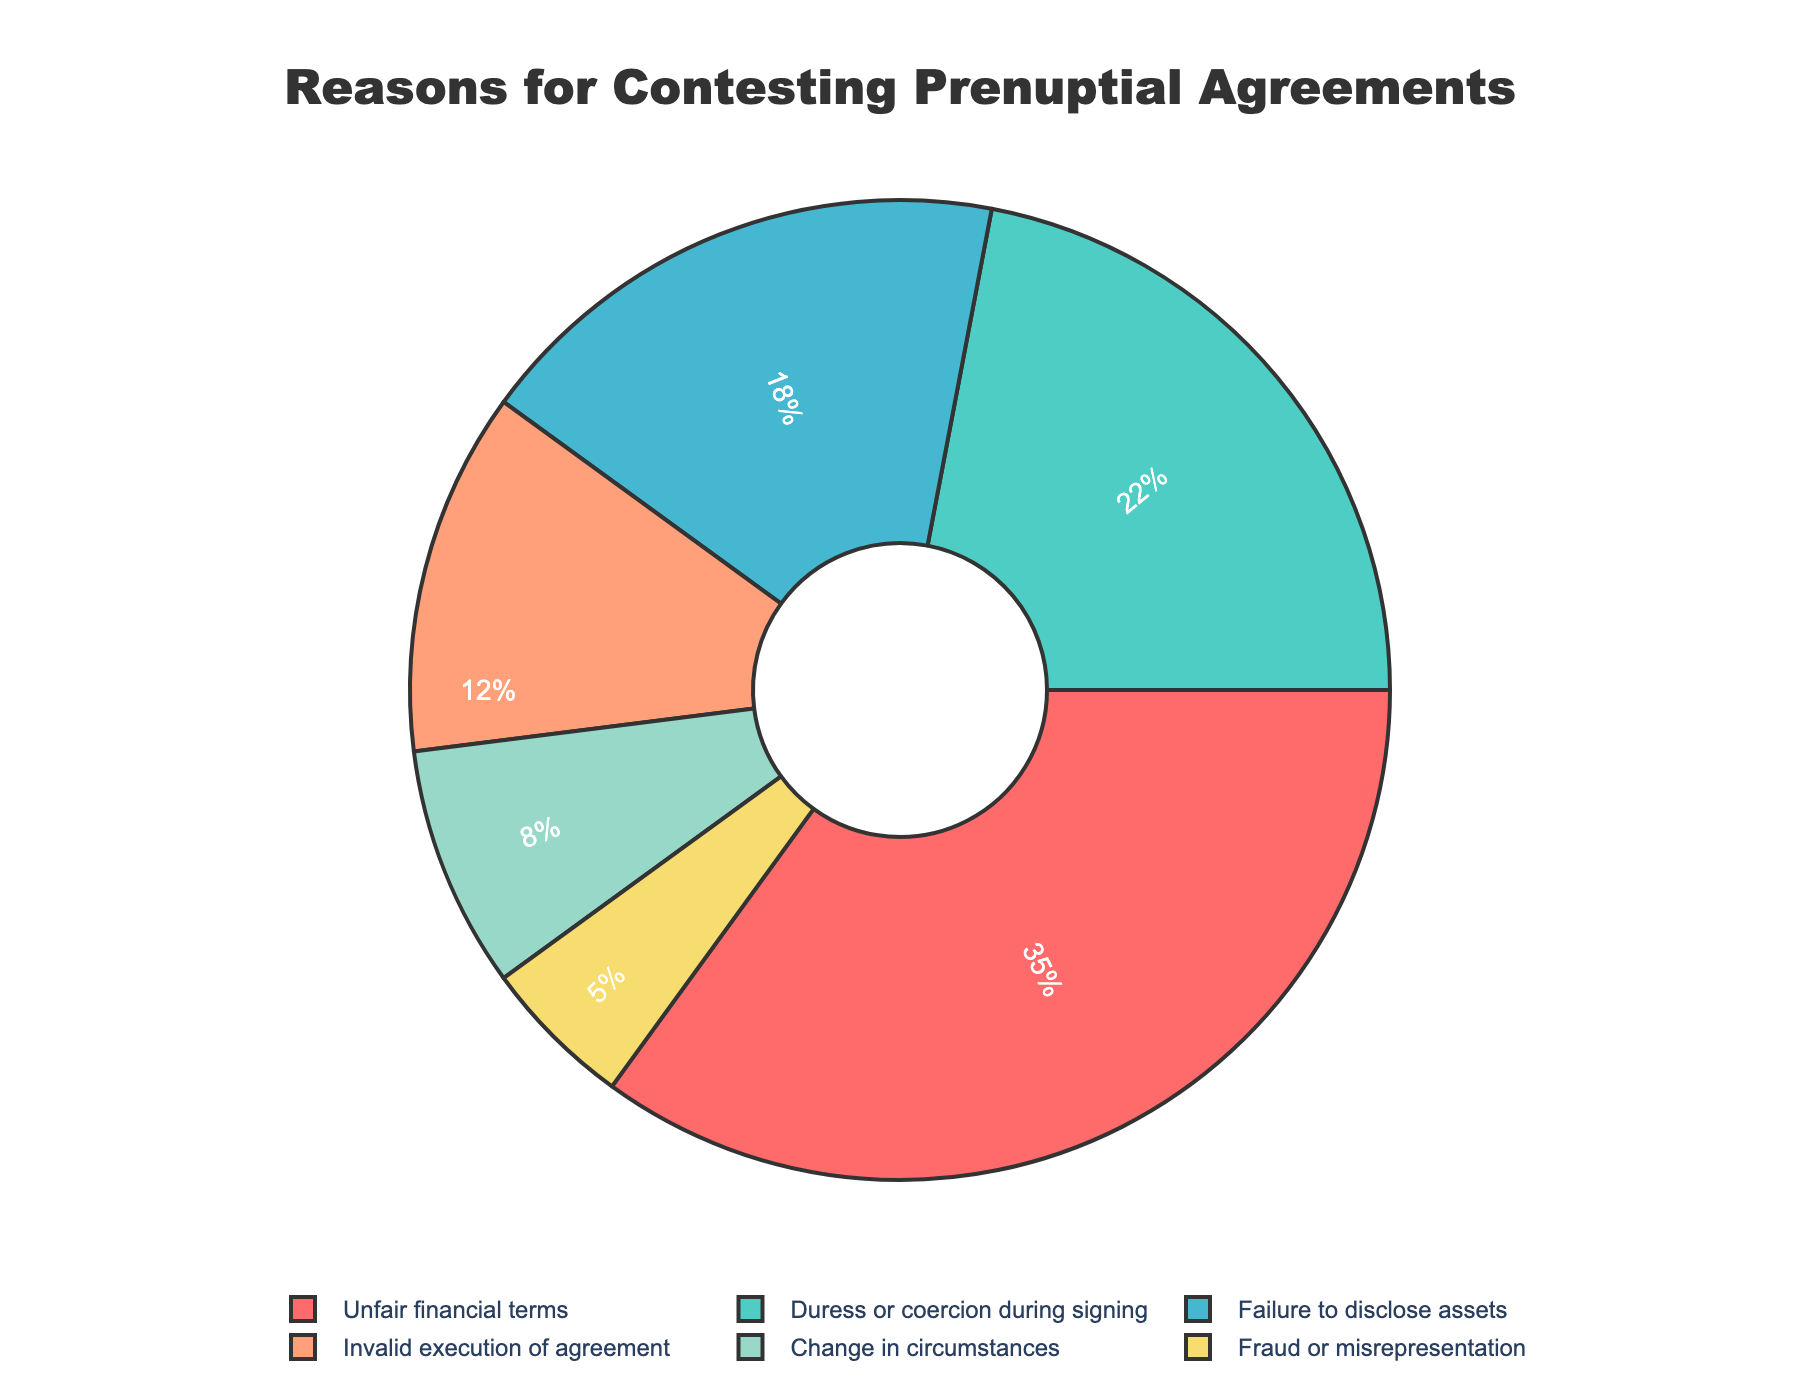What is the largest reason for contesting prenuptial agreements? The slice for 'Unfair financial terms' is the largest in the pie chart, taking up 35% of the whole.
Answer: Unfair financial terms Which reason is the smallest and what is its percentage? The slice for 'Fraud or misrepresentation' is visually the smallest and has a percentage of 5%.
Answer: Fraud or misrepresentation at 5% How much more common is 'Unfair financial terms' compared to 'Change in circumstances'? The 'Unfair financial terms' percentage is 35%, while 'Change in circumstances' is 8%. The difference is 35% - 8% = 27%.
Answer: 27% Combine the percentages of 'Duress or coercion during signing' and 'Invalid execution of agreement'. What is the total? 'Duress or coercion during signing' is 22% and 'Invalid execution of agreement' is 12%. Adding them together, 22% + 12% = 34%.
Answer: 34% Which two reasons have percentages that add up to the same as 'Unfair financial terms'? 'Failure to disclose assets' is 18% and 'Duress or coercion during signing' is 22%. 18% + 22% = 40%, which is greater. 'Invalid execution of agreement' is 12% and 'Change in circumstances' is 8%. 12% + 8% = 20%, which is less. 'Invalid execution of agreement' is 12% + 'Failure to disclose assets' is 18%. 12% + 18% = 30%, closest combination is first one.
Answer: No exact match Compare the size of the slices for 'Duress or coercion during signing' and 'Failure to disclose assets.' Which one is bigger and by how much? 'Duress or coercion during signing' is 22%, and 'Failure to disclose assets' is 18%. 22% - 18% = 4%.
Answer: Duress or coercion during signing by 4% What is the combined percentage of the three smallest reasons? The three smallest reasons are 'Fraud or misrepresentation' at 5%, 'Change in circumstances' at 8%, and 'Invalid execution of agreement' at 12%. Summing them up, 5% + 8% + 12% = 25%.
Answer: 25% Which color represents the reason 'Change in circumstances' in the chart? 'Change in circumstances' has a smaller slice with a yellowish color. Based on the colors provided, the corresponding color is yellow.
Answer: Yellow How much less frequent is 'Failure to disclose assets' compared to 'Unfair financial terms'? 'Unfair financial terms' is 35%, and 'Failure to disclose assets' is 18%. The difference is 35% - 18% = 17%.
Answer: 17% If you combine 'Invalid execution of agreement' and 'Fraud or misrepresentation,' would their percentage be more or less than that of 'Duress or coercion during signing'? 'Invalid execution of agreement' is 12% and 'Fraud or misrepresentation' is 5%, so combined they are 12% + 5% = 17%. 'Duress or coercion during signing' is 22%, so they are less.
Answer: Less 